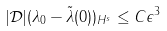Convert formula to latex. <formula><loc_0><loc_0><loc_500><loc_500>\| \, | \mathcal { D } | ( \lambda _ { 0 } - \tilde { \lambda } ( 0 ) ) \| _ { H ^ { s } } \leq C \epsilon ^ { 3 }</formula> 